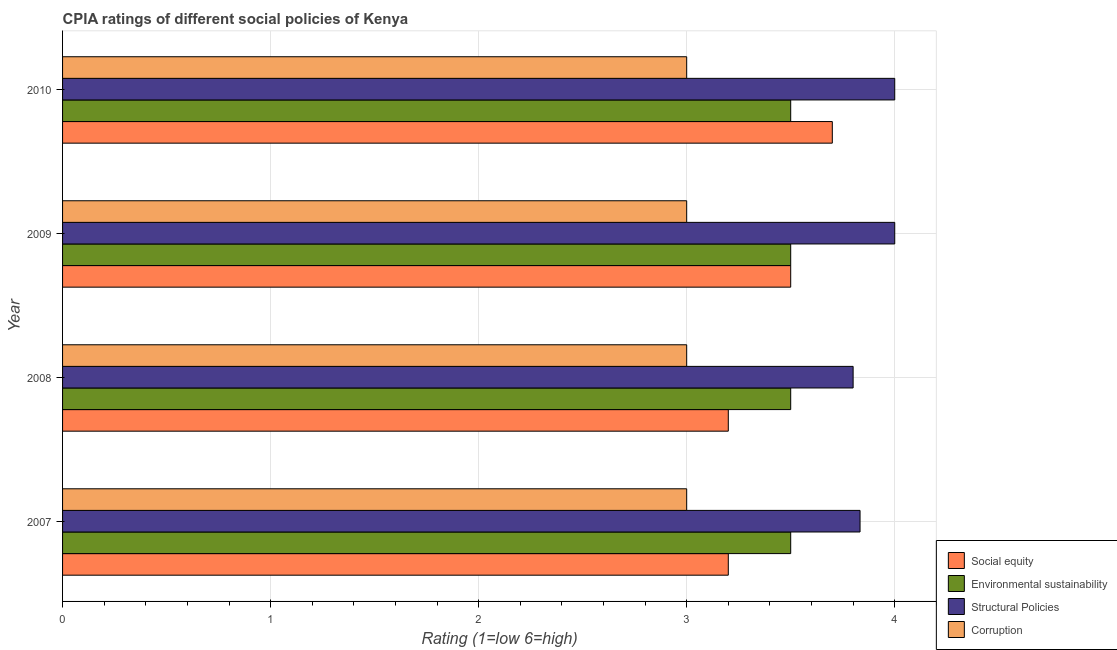Are the number of bars per tick equal to the number of legend labels?
Your answer should be very brief. Yes. How many bars are there on the 2nd tick from the top?
Offer a terse response. 4. Across all years, what is the maximum cpia rating of corruption?
Make the answer very short. 3. Across all years, what is the minimum cpia rating of structural policies?
Make the answer very short. 3.8. In which year was the cpia rating of structural policies minimum?
Keep it short and to the point. 2008. What is the total cpia rating of corruption in the graph?
Your response must be concise. 12. What is the difference between the cpia rating of social equity in 2009 and the cpia rating of corruption in 2008?
Give a very brief answer. 0.5. What is the average cpia rating of corruption per year?
Give a very brief answer. 3. What is the ratio of the cpia rating of social equity in 2008 to that in 2009?
Your answer should be compact. 0.91. Is the cpia rating of structural policies in 2009 less than that in 2010?
Make the answer very short. No. Is the difference between the cpia rating of environmental sustainability in 2009 and 2010 greater than the difference between the cpia rating of social equity in 2009 and 2010?
Keep it short and to the point. Yes. What is the difference between the highest and the second highest cpia rating of corruption?
Provide a succinct answer. 0. What is the difference between the highest and the lowest cpia rating of social equity?
Give a very brief answer. 0.5. What does the 3rd bar from the top in 2010 represents?
Make the answer very short. Environmental sustainability. What does the 1st bar from the bottom in 2008 represents?
Keep it short and to the point. Social equity. How many years are there in the graph?
Your answer should be very brief. 4. Are the values on the major ticks of X-axis written in scientific E-notation?
Offer a terse response. No. Does the graph contain grids?
Ensure brevity in your answer.  Yes. Where does the legend appear in the graph?
Your answer should be compact. Bottom right. How are the legend labels stacked?
Provide a short and direct response. Vertical. What is the title of the graph?
Your response must be concise. CPIA ratings of different social policies of Kenya. What is the Rating (1=low 6=high) in Structural Policies in 2007?
Your response must be concise. 3.83. What is the Rating (1=low 6=high) in Environmental sustainability in 2009?
Provide a succinct answer. 3.5. What is the Rating (1=low 6=high) in Corruption in 2009?
Your answer should be compact. 3. What is the Rating (1=low 6=high) in Environmental sustainability in 2010?
Provide a short and direct response. 3.5. What is the Rating (1=low 6=high) of Corruption in 2010?
Make the answer very short. 3. Across all years, what is the maximum Rating (1=low 6=high) in Structural Policies?
Give a very brief answer. 4. Across all years, what is the maximum Rating (1=low 6=high) of Corruption?
Ensure brevity in your answer.  3. Across all years, what is the minimum Rating (1=low 6=high) in Social equity?
Offer a very short reply. 3.2. Across all years, what is the minimum Rating (1=low 6=high) in Structural Policies?
Offer a very short reply. 3.8. Across all years, what is the minimum Rating (1=low 6=high) of Corruption?
Provide a succinct answer. 3. What is the total Rating (1=low 6=high) of Environmental sustainability in the graph?
Offer a very short reply. 14. What is the total Rating (1=low 6=high) of Structural Policies in the graph?
Offer a terse response. 15.63. What is the total Rating (1=low 6=high) in Corruption in the graph?
Ensure brevity in your answer.  12. What is the difference between the Rating (1=low 6=high) of Environmental sustainability in 2007 and that in 2009?
Make the answer very short. 0. What is the difference between the Rating (1=low 6=high) in Corruption in 2007 and that in 2010?
Give a very brief answer. 0. What is the difference between the Rating (1=low 6=high) in Social equity in 2008 and that in 2009?
Make the answer very short. -0.3. What is the difference between the Rating (1=low 6=high) of Environmental sustainability in 2008 and that in 2009?
Offer a very short reply. 0. What is the difference between the Rating (1=low 6=high) of Structural Policies in 2008 and that in 2009?
Your response must be concise. -0.2. What is the difference between the Rating (1=low 6=high) of Corruption in 2008 and that in 2009?
Provide a short and direct response. 0. What is the difference between the Rating (1=low 6=high) of Environmental sustainability in 2008 and that in 2010?
Your answer should be very brief. 0. What is the difference between the Rating (1=low 6=high) in Corruption in 2008 and that in 2010?
Make the answer very short. 0. What is the difference between the Rating (1=low 6=high) of Social equity in 2009 and that in 2010?
Ensure brevity in your answer.  -0.2. What is the difference between the Rating (1=low 6=high) of Environmental sustainability in 2009 and that in 2010?
Your answer should be compact. 0. What is the difference between the Rating (1=low 6=high) of Structural Policies in 2007 and the Rating (1=low 6=high) of Corruption in 2008?
Provide a succinct answer. 0.83. What is the difference between the Rating (1=low 6=high) of Social equity in 2007 and the Rating (1=low 6=high) of Environmental sustainability in 2009?
Provide a succinct answer. -0.3. What is the difference between the Rating (1=low 6=high) of Social equity in 2007 and the Rating (1=low 6=high) of Corruption in 2009?
Ensure brevity in your answer.  0.2. What is the difference between the Rating (1=low 6=high) of Environmental sustainability in 2007 and the Rating (1=low 6=high) of Structural Policies in 2009?
Offer a terse response. -0.5. What is the difference between the Rating (1=low 6=high) in Social equity in 2007 and the Rating (1=low 6=high) in Environmental sustainability in 2010?
Keep it short and to the point. -0.3. What is the difference between the Rating (1=low 6=high) in Environmental sustainability in 2007 and the Rating (1=low 6=high) in Corruption in 2010?
Make the answer very short. 0.5. What is the difference between the Rating (1=low 6=high) in Structural Policies in 2007 and the Rating (1=low 6=high) in Corruption in 2010?
Make the answer very short. 0.83. What is the difference between the Rating (1=low 6=high) in Social equity in 2008 and the Rating (1=low 6=high) in Environmental sustainability in 2009?
Your answer should be compact. -0.3. What is the difference between the Rating (1=low 6=high) in Social equity in 2008 and the Rating (1=low 6=high) in Structural Policies in 2009?
Give a very brief answer. -0.8. What is the difference between the Rating (1=low 6=high) of Social equity in 2008 and the Rating (1=low 6=high) of Corruption in 2010?
Keep it short and to the point. 0.2. What is the difference between the Rating (1=low 6=high) in Environmental sustainability in 2008 and the Rating (1=low 6=high) in Corruption in 2010?
Provide a succinct answer. 0.5. What is the difference between the Rating (1=low 6=high) of Structural Policies in 2008 and the Rating (1=low 6=high) of Corruption in 2010?
Offer a terse response. 0.8. What is the difference between the Rating (1=low 6=high) in Social equity in 2009 and the Rating (1=low 6=high) in Environmental sustainability in 2010?
Ensure brevity in your answer.  0. What is the difference between the Rating (1=low 6=high) of Social equity in 2009 and the Rating (1=low 6=high) of Structural Policies in 2010?
Provide a succinct answer. -0.5. What is the difference between the Rating (1=low 6=high) in Environmental sustainability in 2009 and the Rating (1=low 6=high) in Structural Policies in 2010?
Offer a very short reply. -0.5. What is the difference between the Rating (1=low 6=high) of Environmental sustainability in 2009 and the Rating (1=low 6=high) of Corruption in 2010?
Offer a terse response. 0.5. What is the difference between the Rating (1=low 6=high) in Structural Policies in 2009 and the Rating (1=low 6=high) in Corruption in 2010?
Your answer should be very brief. 1. What is the average Rating (1=low 6=high) in Environmental sustainability per year?
Give a very brief answer. 3.5. What is the average Rating (1=low 6=high) in Structural Policies per year?
Keep it short and to the point. 3.91. What is the average Rating (1=low 6=high) of Corruption per year?
Offer a terse response. 3. In the year 2007, what is the difference between the Rating (1=low 6=high) in Social equity and Rating (1=low 6=high) in Environmental sustainability?
Provide a succinct answer. -0.3. In the year 2007, what is the difference between the Rating (1=low 6=high) in Social equity and Rating (1=low 6=high) in Structural Policies?
Your answer should be very brief. -0.63. In the year 2007, what is the difference between the Rating (1=low 6=high) in Environmental sustainability and Rating (1=low 6=high) in Structural Policies?
Give a very brief answer. -0.33. In the year 2007, what is the difference between the Rating (1=low 6=high) in Environmental sustainability and Rating (1=low 6=high) in Corruption?
Provide a succinct answer. 0.5. In the year 2008, what is the difference between the Rating (1=low 6=high) of Social equity and Rating (1=low 6=high) of Environmental sustainability?
Keep it short and to the point. -0.3. In the year 2008, what is the difference between the Rating (1=low 6=high) in Environmental sustainability and Rating (1=low 6=high) in Structural Policies?
Give a very brief answer. -0.3. In the year 2008, what is the difference between the Rating (1=low 6=high) of Environmental sustainability and Rating (1=low 6=high) of Corruption?
Your response must be concise. 0.5. In the year 2009, what is the difference between the Rating (1=low 6=high) of Social equity and Rating (1=low 6=high) of Environmental sustainability?
Offer a terse response. 0. In the year 2009, what is the difference between the Rating (1=low 6=high) of Social equity and Rating (1=low 6=high) of Structural Policies?
Provide a short and direct response. -0.5. In the year 2009, what is the difference between the Rating (1=low 6=high) in Social equity and Rating (1=low 6=high) in Corruption?
Offer a terse response. 0.5. In the year 2009, what is the difference between the Rating (1=low 6=high) in Structural Policies and Rating (1=low 6=high) in Corruption?
Offer a very short reply. 1. In the year 2010, what is the difference between the Rating (1=low 6=high) of Social equity and Rating (1=low 6=high) of Corruption?
Ensure brevity in your answer.  0.7. In the year 2010, what is the difference between the Rating (1=low 6=high) of Environmental sustainability and Rating (1=low 6=high) of Structural Policies?
Provide a succinct answer. -0.5. In the year 2010, what is the difference between the Rating (1=low 6=high) in Environmental sustainability and Rating (1=low 6=high) in Corruption?
Your answer should be compact. 0.5. In the year 2010, what is the difference between the Rating (1=low 6=high) in Structural Policies and Rating (1=low 6=high) in Corruption?
Provide a succinct answer. 1. What is the ratio of the Rating (1=low 6=high) of Structural Policies in 2007 to that in 2008?
Keep it short and to the point. 1.01. What is the ratio of the Rating (1=low 6=high) in Corruption in 2007 to that in 2008?
Provide a succinct answer. 1. What is the ratio of the Rating (1=low 6=high) of Social equity in 2007 to that in 2009?
Your answer should be compact. 0.91. What is the ratio of the Rating (1=low 6=high) of Environmental sustainability in 2007 to that in 2009?
Your answer should be compact. 1. What is the ratio of the Rating (1=low 6=high) in Social equity in 2007 to that in 2010?
Keep it short and to the point. 0.86. What is the ratio of the Rating (1=low 6=high) of Environmental sustainability in 2007 to that in 2010?
Keep it short and to the point. 1. What is the ratio of the Rating (1=low 6=high) of Structural Policies in 2007 to that in 2010?
Make the answer very short. 0.96. What is the ratio of the Rating (1=low 6=high) of Corruption in 2007 to that in 2010?
Provide a succinct answer. 1. What is the ratio of the Rating (1=low 6=high) of Social equity in 2008 to that in 2009?
Offer a very short reply. 0.91. What is the ratio of the Rating (1=low 6=high) in Corruption in 2008 to that in 2009?
Keep it short and to the point. 1. What is the ratio of the Rating (1=low 6=high) in Social equity in 2008 to that in 2010?
Provide a short and direct response. 0.86. What is the ratio of the Rating (1=low 6=high) in Environmental sustainability in 2008 to that in 2010?
Ensure brevity in your answer.  1. What is the ratio of the Rating (1=low 6=high) of Structural Policies in 2008 to that in 2010?
Offer a terse response. 0.95. What is the ratio of the Rating (1=low 6=high) of Corruption in 2008 to that in 2010?
Offer a very short reply. 1. What is the ratio of the Rating (1=low 6=high) in Social equity in 2009 to that in 2010?
Your answer should be compact. 0.95. What is the ratio of the Rating (1=low 6=high) in Environmental sustainability in 2009 to that in 2010?
Keep it short and to the point. 1. What is the ratio of the Rating (1=low 6=high) of Structural Policies in 2009 to that in 2010?
Keep it short and to the point. 1. What is the difference between the highest and the second highest Rating (1=low 6=high) in Corruption?
Make the answer very short. 0. What is the difference between the highest and the lowest Rating (1=low 6=high) in Social equity?
Offer a terse response. 0.5. What is the difference between the highest and the lowest Rating (1=low 6=high) of Structural Policies?
Provide a succinct answer. 0.2. 